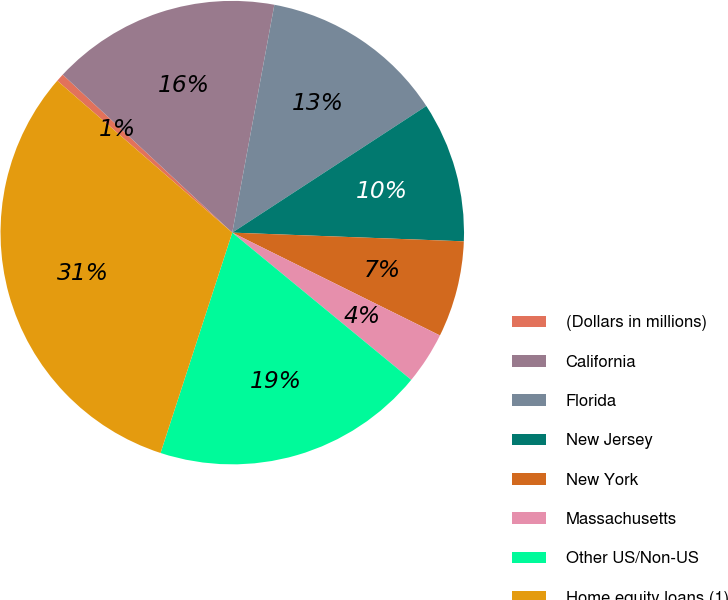<chart> <loc_0><loc_0><loc_500><loc_500><pie_chart><fcel>(Dollars in millions)<fcel>California<fcel>Florida<fcel>New Jersey<fcel>New York<fcel>Massachusetts<fcel>Other US/Non-US<fcel>Home equity loans (1)<nl><fcel>0.56%<fcel>15.97%<fcel>12.89%<fcel>9.8%<fcel>6.72%<fcel>3.64%<fcel>19.05%<fcel>31.37%<nl></chart> 